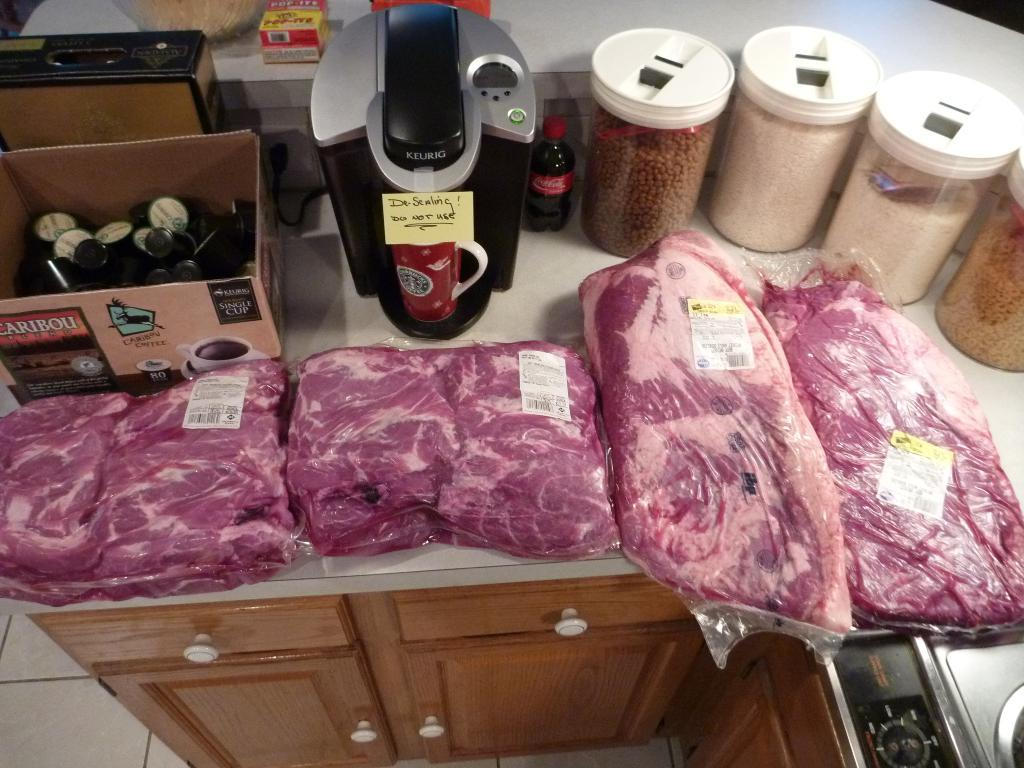<image>
Present a compact description of the photo's key features. Four slabs of meat share a counter with a Keurig machine and an open box of Caribou K-pods. 